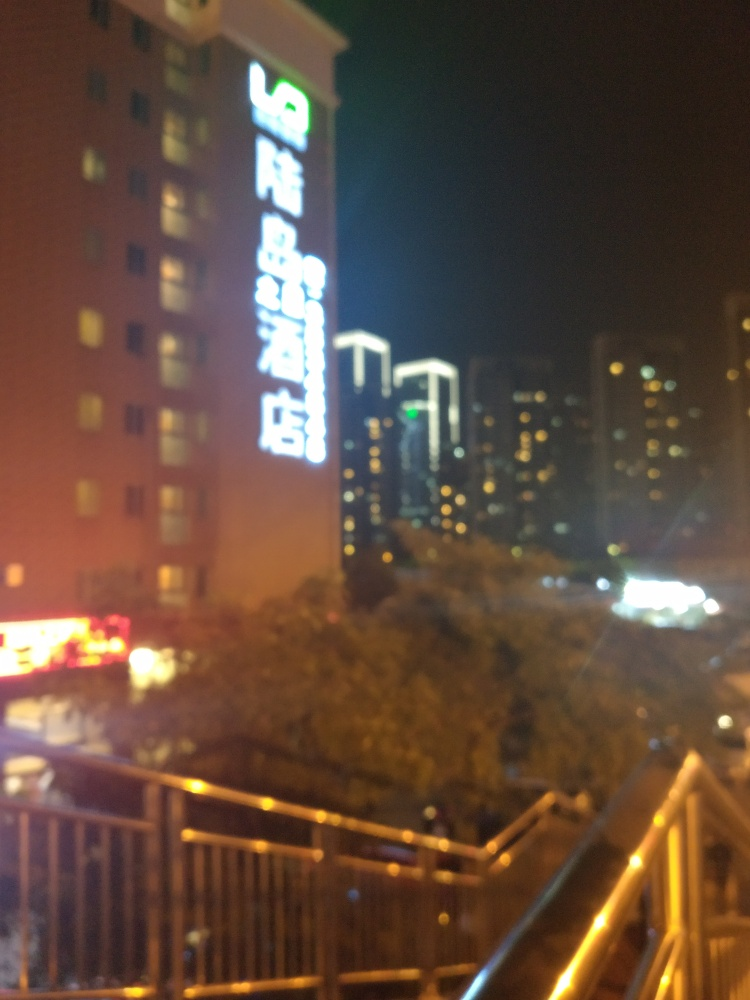Are there any quality issues with this image? Yes, the image suffers from significant blurriness which affects the clarity of details. This could be due to motion blur, out-of-focus capture, or a low-quality camera sensor. It's difficult to discern specific features or read the text clearly. 